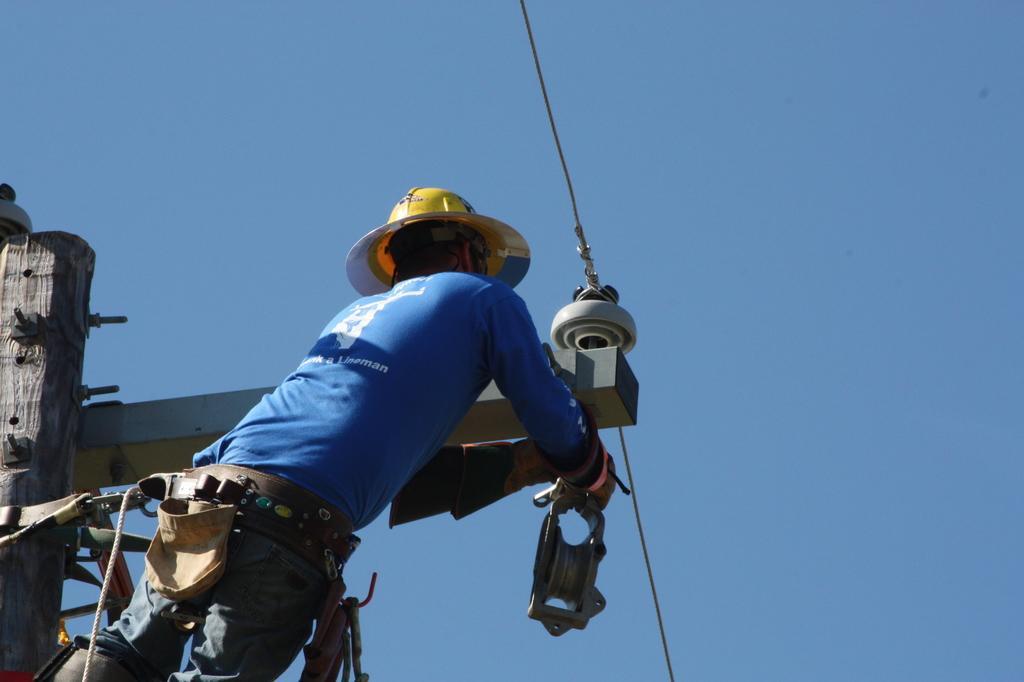How would you summarize this image in a sentence or two? In this image there is a man standing, he is holding an object, there is a pole towards the left of the image, there is a rope towards the bottom of the image, there are wires, there is the sky. 